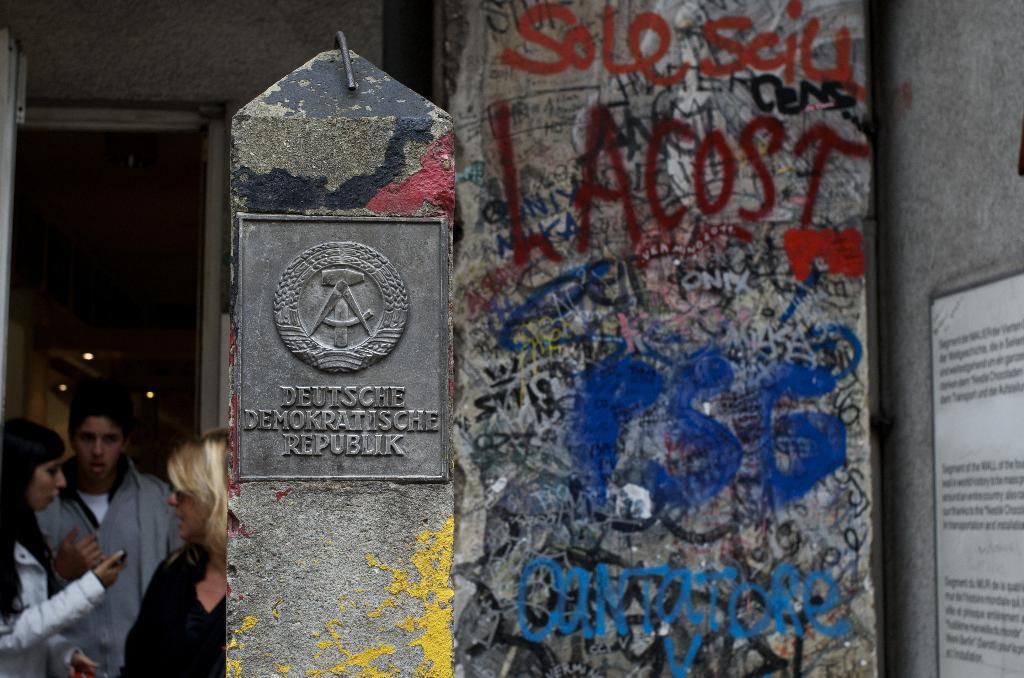Could you give a brief overview of what you see in this image? In this picture I can see three persons standing, there are lights, there are some scribblings on the wall, there is a board attached to the wall, this is looking like a board which is on the pillar. 